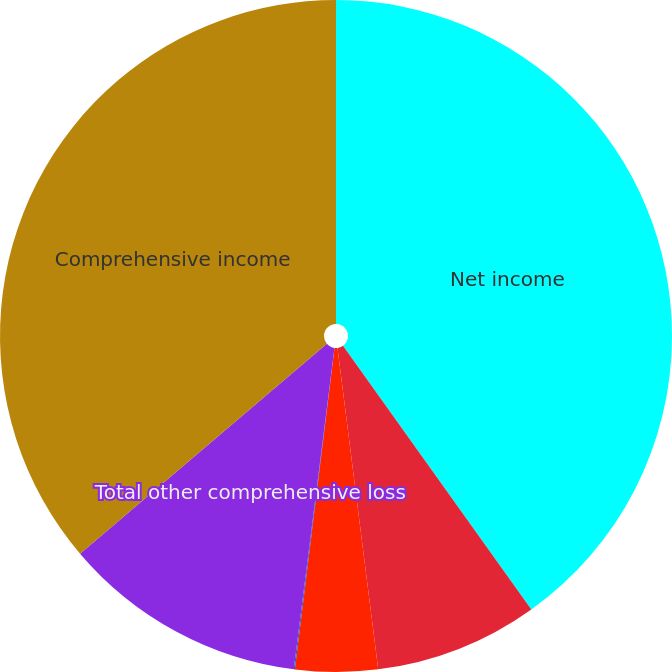Convert chart. <chart><loc_0><loc_0><loc_500><loc_500><pie_chart><fcel>Net income<fcel>Foreign currency translation<fcel>Changes in unrealized holding<fcel>Changes in defined benefit<fcel>Total other comprehensive loss<fcel>Comprehensive income<nl><fcel>40.13%<fcel>7.87%<fcel>3.96%<fcel>0.05%<fcel>11.78%<fcel>36.22%<nl></chart> 